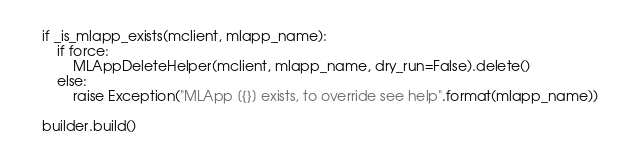<code> <loc_0><loc_0><loc_500><loc_500><_Python_>
    if _is_mlapp_exists(mclient, mlapp_name):
        if force:
            MLAppDeleteHelper(mclient, mlapp_name, dry_run=False).delete()
        else:
            raise Exception("MLApp [{}] exists, to override see help".format(mlapp_name))

    builder.build()
</code> 